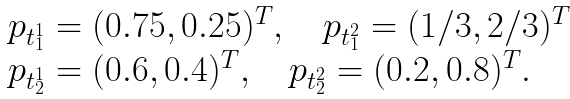Convert formula to latex. <formula><loc_0><loc_0><loc_500><loc_500>\begin{array} { l } p _ { t _ { 1 } ^ { 1 } } = ( 0 . 7 5 , 0 . 2 5 ) ^ { T } , \quad p _ { t _ { 1 } ^ { 2 } } = ( 1 / 3 , 2 / 3 ) ^ { T } \\ p _ { t _ { 2 } ^ { 1 } } = ( 0 . 6 , 0 . 4 ) ^ { T } , \quad p _ { t _ { 2 } ^ { 2 } } = ( 0 . 2 , 0 . 8 ) ^ { T } . \end{array}</formula> 